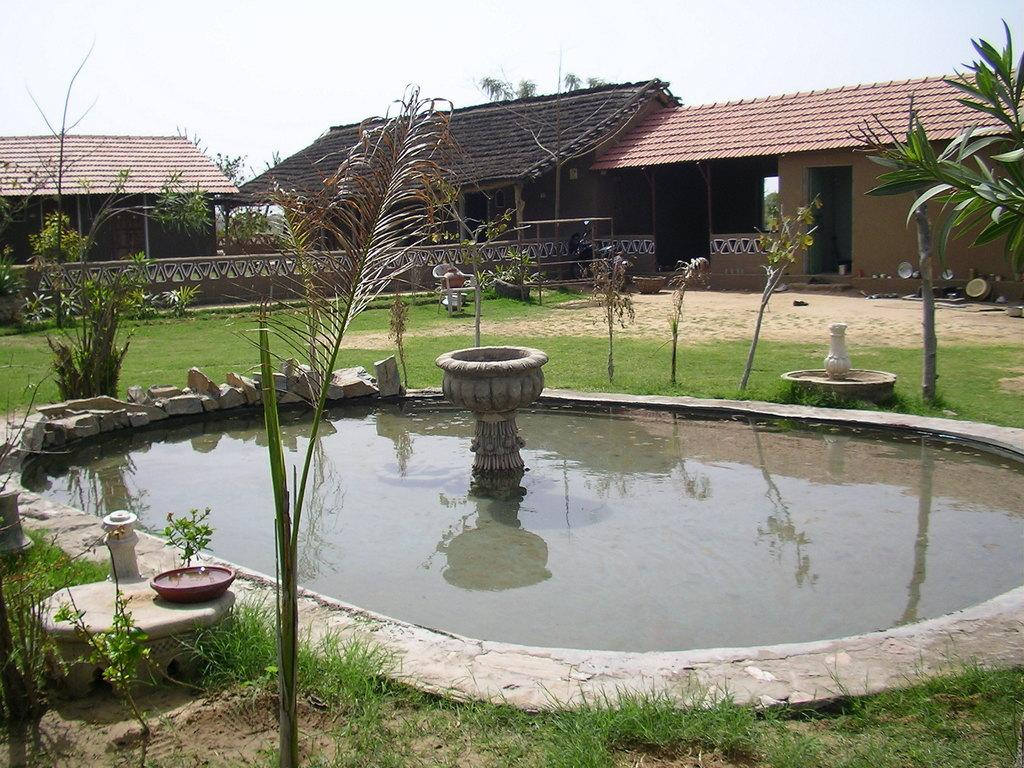What type of body of water is present in the image? There is a pond in the image. What other natural elements can be seen in the image? There are stones, grass, and plants in the image. Are there any man-made structures visible in the image? Yes, there are buildings in the image. What part of the natural environment is visible in the image? The sky is visible in the image. What is the name of the ocean that can be seen in the image? There is no ocean present in the image; it features a pond. What is the tendency of the plants to grow in the image? The image does not provide information about the growth tendency of the plants; it only shows their presence. 